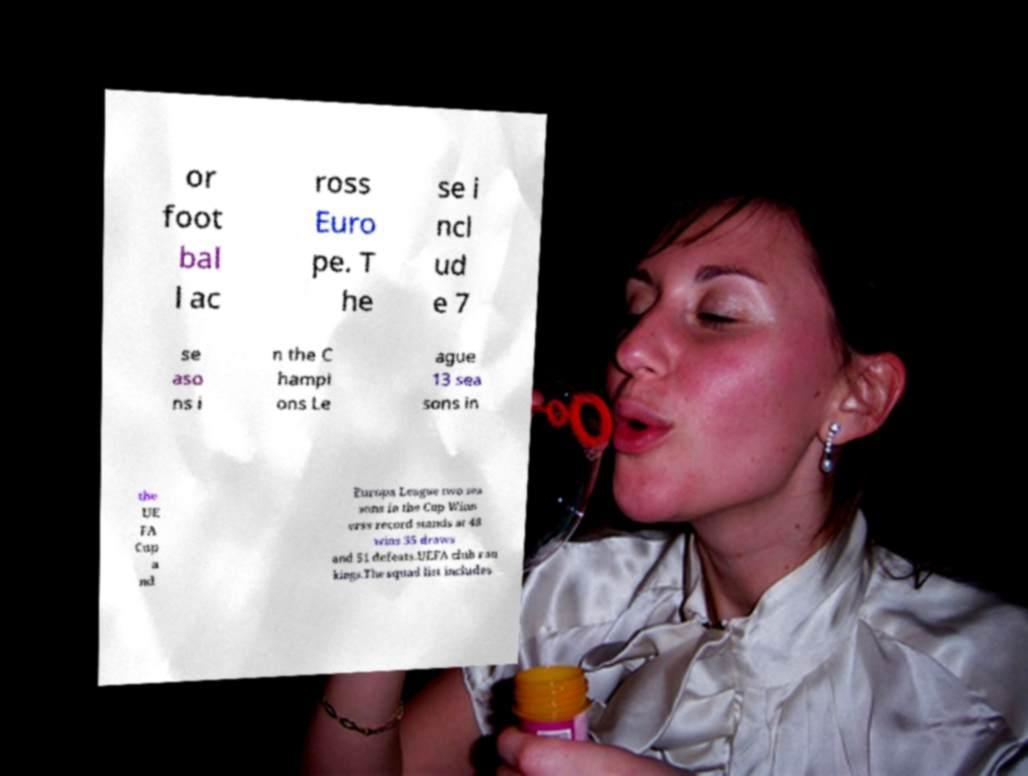Can you accurately transcribe the text from the provided image for me? or foot bal l ac ross Euro pe. T he se i ncl ud e 7 se aso ns i n the C hampi ons Le ague 13 sea sons in the UE FA Cup a nd Europa League two sea sons in the Cup Winn erss record stands at 48 wins 35 draws and 51 defeats.UEFA club ran kings.The squad list includes 